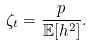Convert formula to latex. <formula><loc_0><loc_0><loc_500><loc_500>\zeta _ { t } = \frac { p } { \mathbb { E } [ h ^ { 2 } ] } .</formula> 